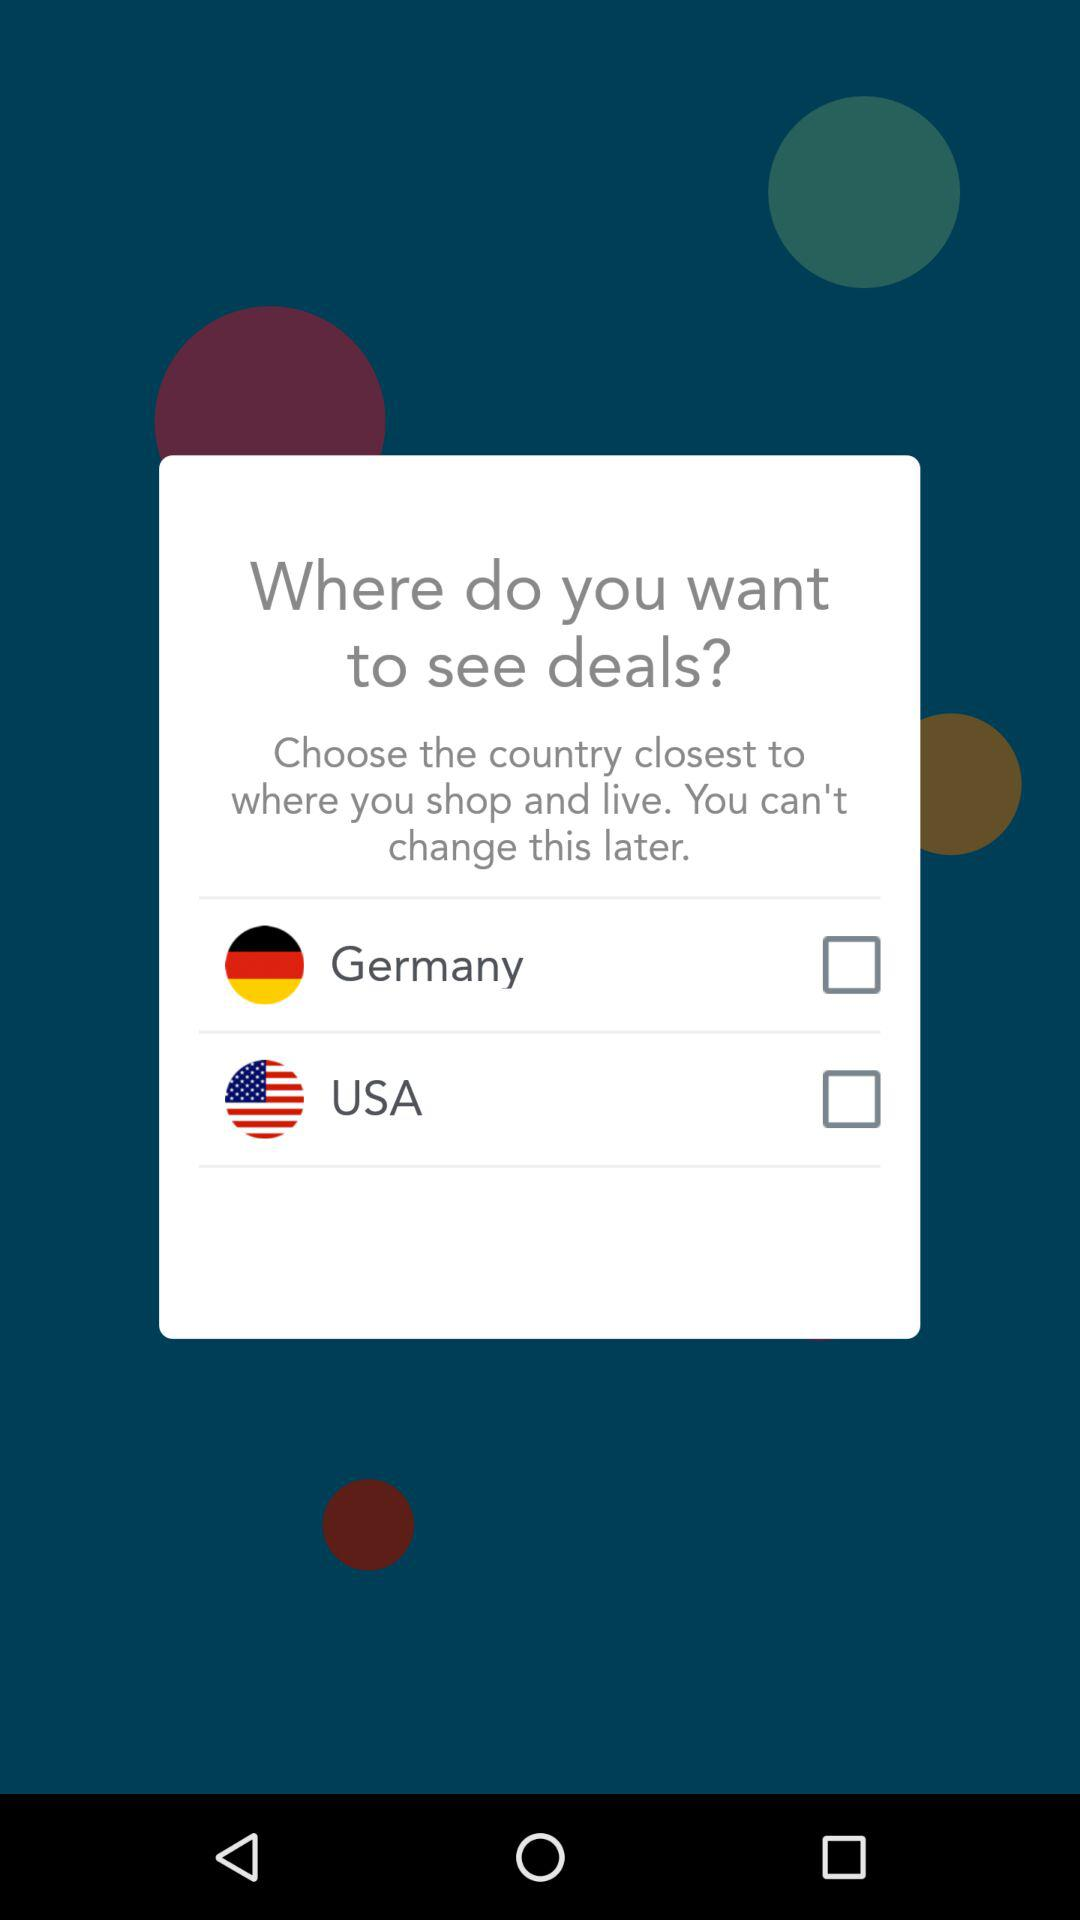How many countries are available to select?
Answer the question using a single word or phrase. 2 